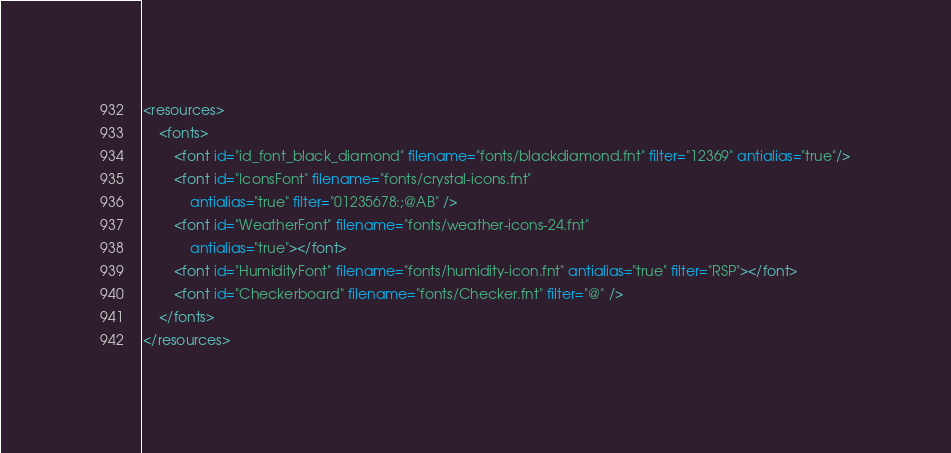<code> <loc_0><loc_0><loc_500><loc_500><_XML_><resources>
    <fonts>
        <font id="id_font_black_diamond" filename="fonts/blackdiamond.fnt" filter="12369" antialias="true"/>
        <font id="IconsFont" filename="fonts/crystal-icons.fnt"
        	antialias="true" filter="01235678:;@AB" />
        <font id="WeatherFont" filename="fonts/weather-icons-24.fnt"
        	antialias="true"></font>
        <font id="HumidityFont" filename="fonts/humidity-icon.fnt" antialias="true" filter="RSP"></font>
        <font id="Checkerboard" filename="fonts/Checker.fnt" filter="@" />
    </fonts>
</resources></code> 